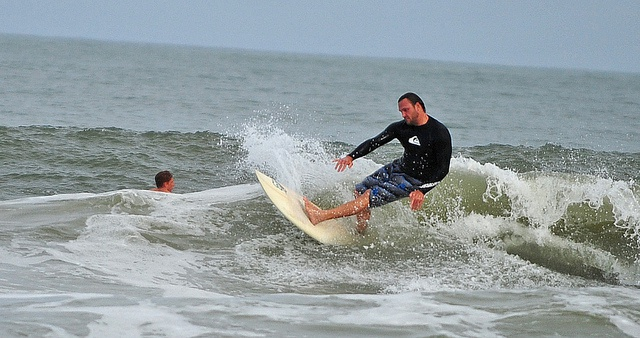Describe the objects in this image and their specific colors. I can see people in darkgray, black, brown, and gray tones, surfboard in darkgray, beige, and tan tones, surfboard in darkgray and lightgray tones, and people in darkgray, black, brown, maroon, and gray tones in this image. 